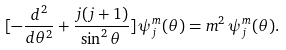<formula> <loc_0><loc_0><loc_500><loc_500>[ - \frac { d ^ { 2 } } { d \theta ^ { 2 } } + \frac { j ( j + 1 ) } { \sin ^ { 2 } \theta } ] \, \psi _ { j } ^ { m } ( \theta ) = m ^ { 2 } \, \psi _ { j } ^ { m } ( \theta ) .</formula> 